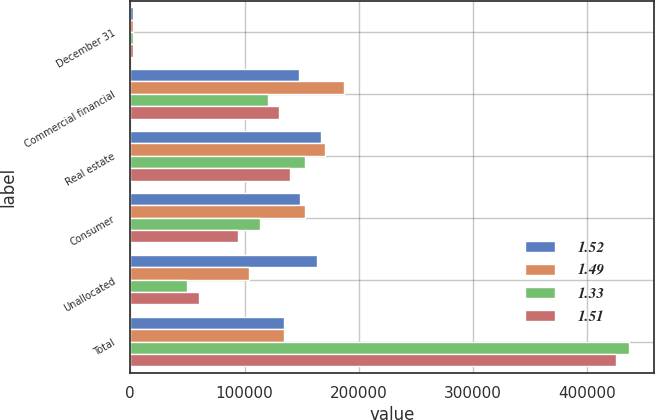<chart> <loc_0><loc_0><loc_500><loc_500><stacked_bar_chart><ecel><fcel>December 31<fcel>Commercial financial<fcel>Real estate<fcel>Consumer<fcel>Unallocated<fcel>Total<nl><fcel>1.52<fcel>2004<fcel>147550<fcel>166910<fcel>148591<fcel>163813<fcel>135002<nl><fcel>1.49<fcel>2003<fcel>186902<fcel>170493<fcel>152759<fcel>103904<fcel>135002<nl><fcel>1.33<fcel>2002<fcel>120627<fcel>152758<fcel>113711<fcel>49376<fcel>436472<nl><fcel>1.51<fcel>2001<fcel>130156<fcel>139848<fcel>94710<fcel>60294<fcel>425008<nl></chart> 